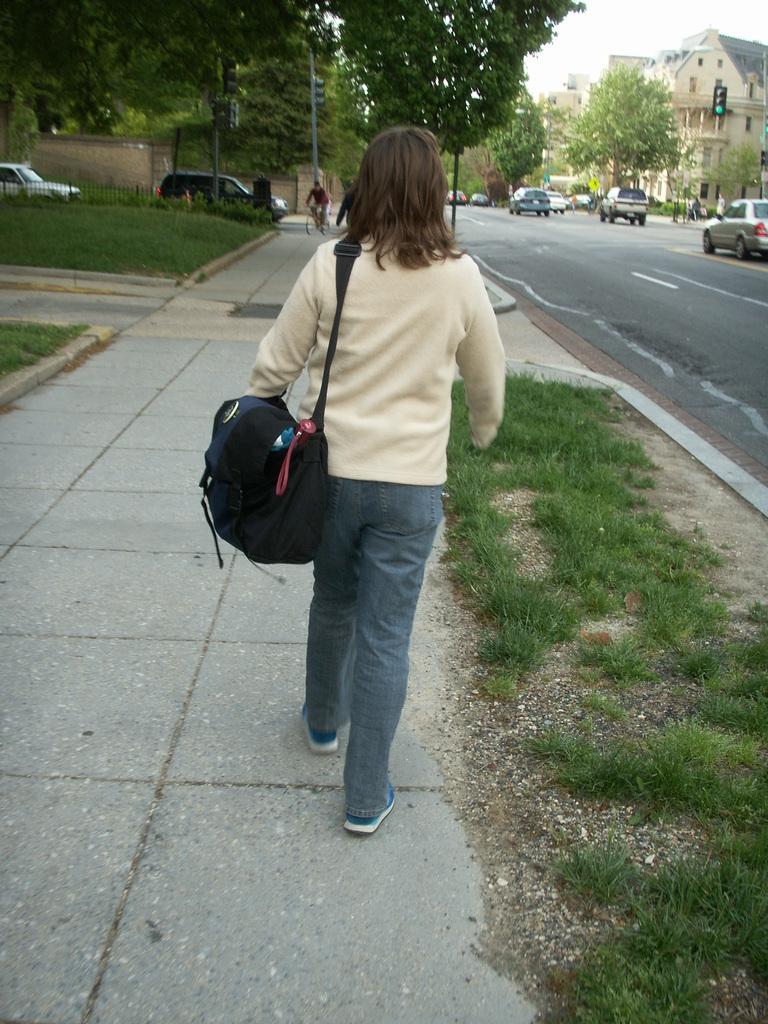Please provide a concise description of this image. In the image we can see a person wearing clothes, shoes and carrying a bag. This is a grass, footpath, road, vehicles on the road, bicycle, trees, buildings, signal pole and a sky. We can even see a person riding the bicycle, this is a fence. 